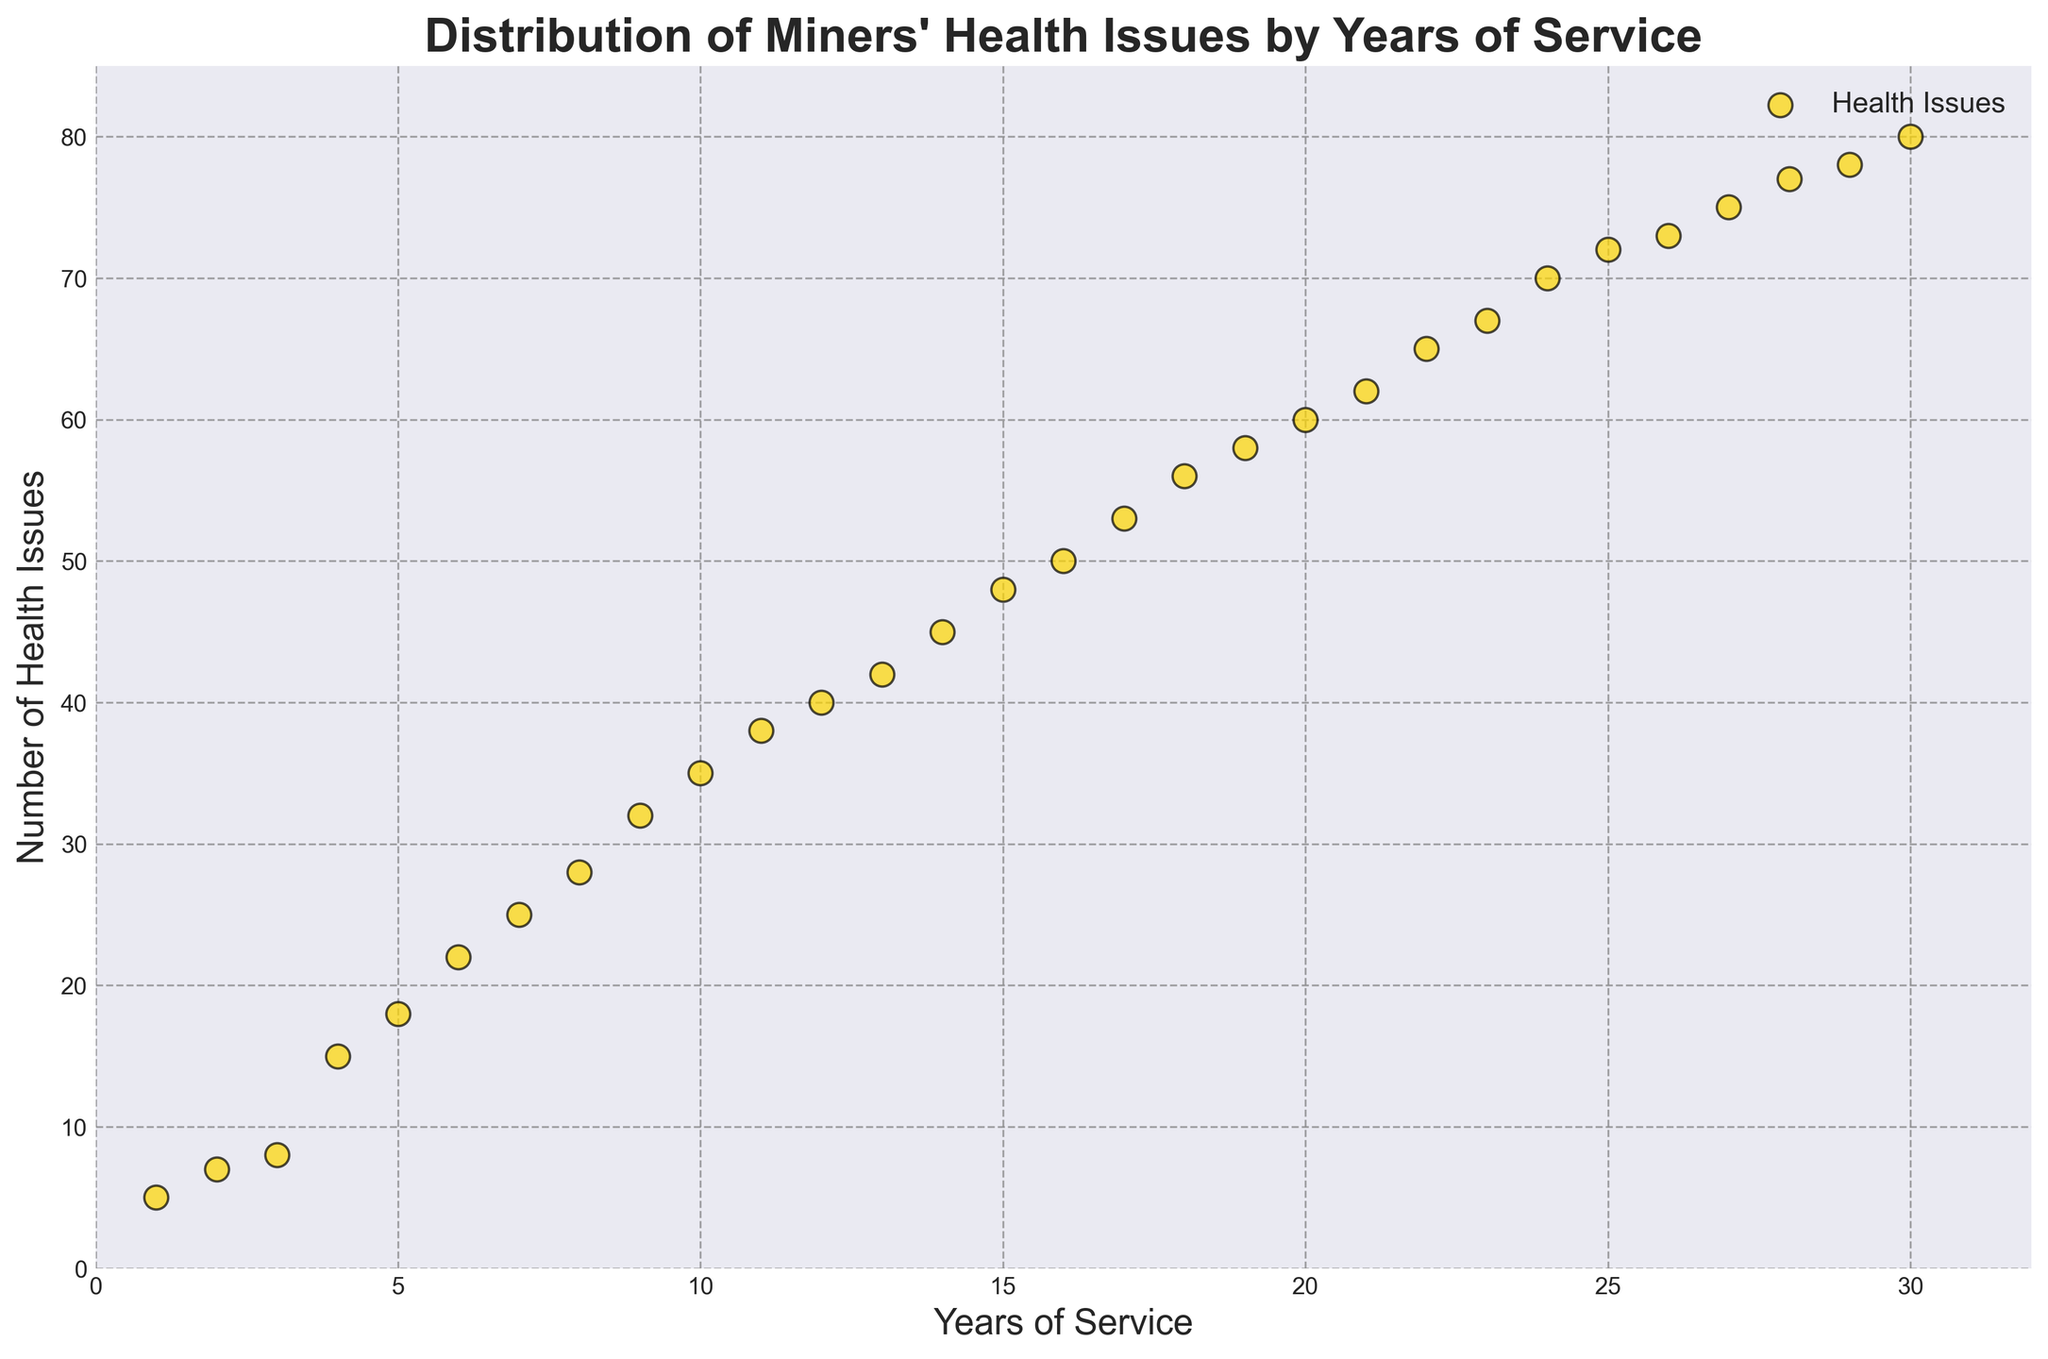What trend can be observed in the number of health issues as years of service increase? As the years of service increase, the scatter plot consistently shows an upward trend in the number of health issues, indicating that longer years of service are associated with a higher count of health issues.
Answer: An increasing trend From the scatter plot, how many health issues are associated with 15 years of service? Locate the data point for 15 years of service on the x-axis and observe the corresponding y-axis value, which is the number of health issues.
Answer: 48 Compare the number of health issues at 10 years of service and 20 years of service. Which one is higher, and by how much? At 10 years of service, there are 35 health issues. At 20 years of service, there are 60 health issues. Subtract the smaller number from the larger number: 60 - 35 = 25.
Answer: 20 years by 25 What is the average number of health issues for services spanning from 5 to 10 years inclusive? Sum the number of health issues from 5 to 10 years of service: 18 + 22 + 25 + 28 + 32 + 35 = 160. Divide by the number of years (6): 160 / 6 ≈ 26.67.
Answer: 26.67 Describe the color and marker used for the data points in the scatter plot. Visually inspect the scatter plot to determine the color and marker style. The data points are gold circles with black edges, marked with 'o'.
Answer: Gold circles with black edges What is the median number of health issues for all the years of service provided in the plot? List the health issues count in ascending order and find the middle value. If the number of data points is even, average the two central numbers. Here, the middle values are 42 and 45. (42 + 45) / 2 = 43.5.
Answer: 43.5 Is there any year of service where the health issues count is exactly 50? Check the data points on the scatter plot to see if any have a count of 50 health issues. The data point for 16 years of service has exactly 50 health issues.
Answer: Yes, 16 years Between 5 and 25 years of service, identify the year with the highest number of health issues. Check the corresponding health issues count for each year between 5 and 25 years of service. The year with the highest number of health issues within this range is 25, with 72 health issues.
Answer: 25 years How does the scatter plot visually represent the increase in health issues as the years of service increase? The scatter points are distributed in a way that shows an upward slope from left to right, indicating an increase in health issues as the years of service increase. This upward distribution visually represents the cumulative effect of prolonged exposure to mining conditions.
Answer: Upward distribution 